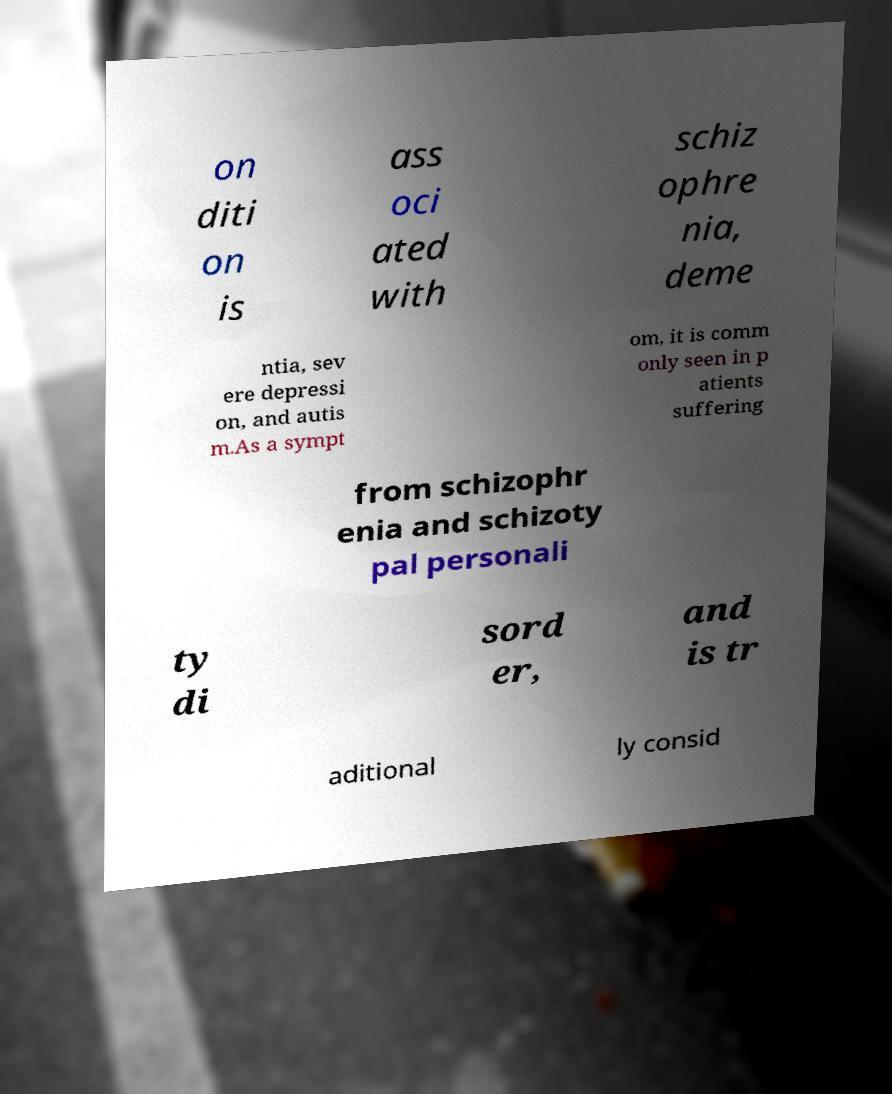Please identify and transcribe the text found in this image. on diti on is ass oci ated with schiz ophre nia, deme ntia, sev ere depressi on, and autis m.As a sympt om, it is comm only seen in p atients suffering from schizophr enia and schizoty pal personali ty di sord er, and is tr aditional ly consid 